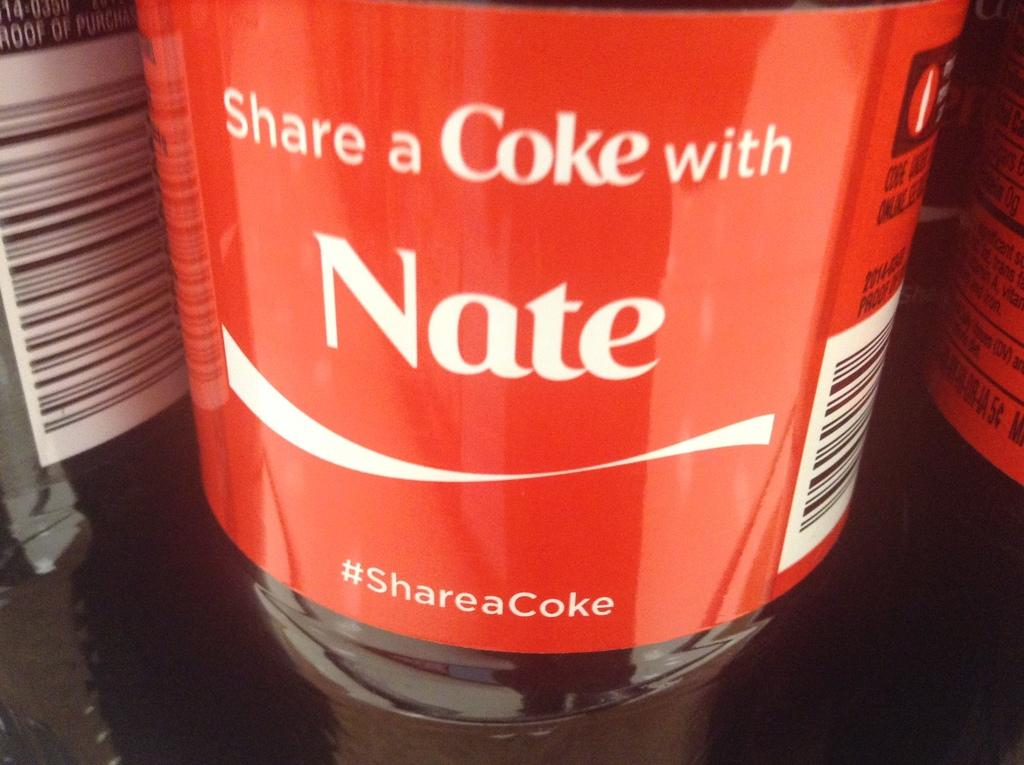How many bottles are present in the image? There are three bottles in the image. Where are the bottles located? The bottles are placed on a table. What is attached to each bottle? Each bottle has a paper attached to it. Can you read the text on the papers? Yes, there is text visible on the papers. How many babies are playing with the bell in the image? There are no babies or bells present in the image. What type of kite is visible in the image? There is no kite visible in the image. 